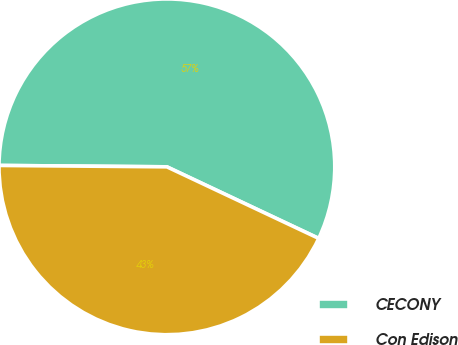Convert chart. <chart><loc_0><loc_0><loc_500><loc_500><pie_chart><fcel>CECONY<fcel>Con Edison<nl><fcel>56.88%<fcel>43.12%<nl></chart> 